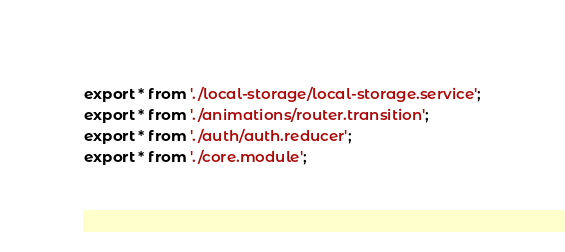<code> <loc_0><loc_0><loc_500><loc_500><_TypeScript_>export * from './local-storage/local-storage.service';
export * from './animations/router.transition';
export * from './auth/auth.reducer';
export * from './core.module';
</code> 